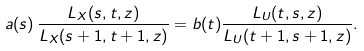<formula> <loc_0><loc_0><loc_500><loc_500>a ( s ) \, \frac { L _ { X } ( s , t , z ) } { L _ { X } ( s + 1 , t + 1 , z ) } = b ( t ) \frac { L _ { U } ( t , s , z ) } { L _ { U } ( t + 1 , s + 1 , z ) } .</formula> 